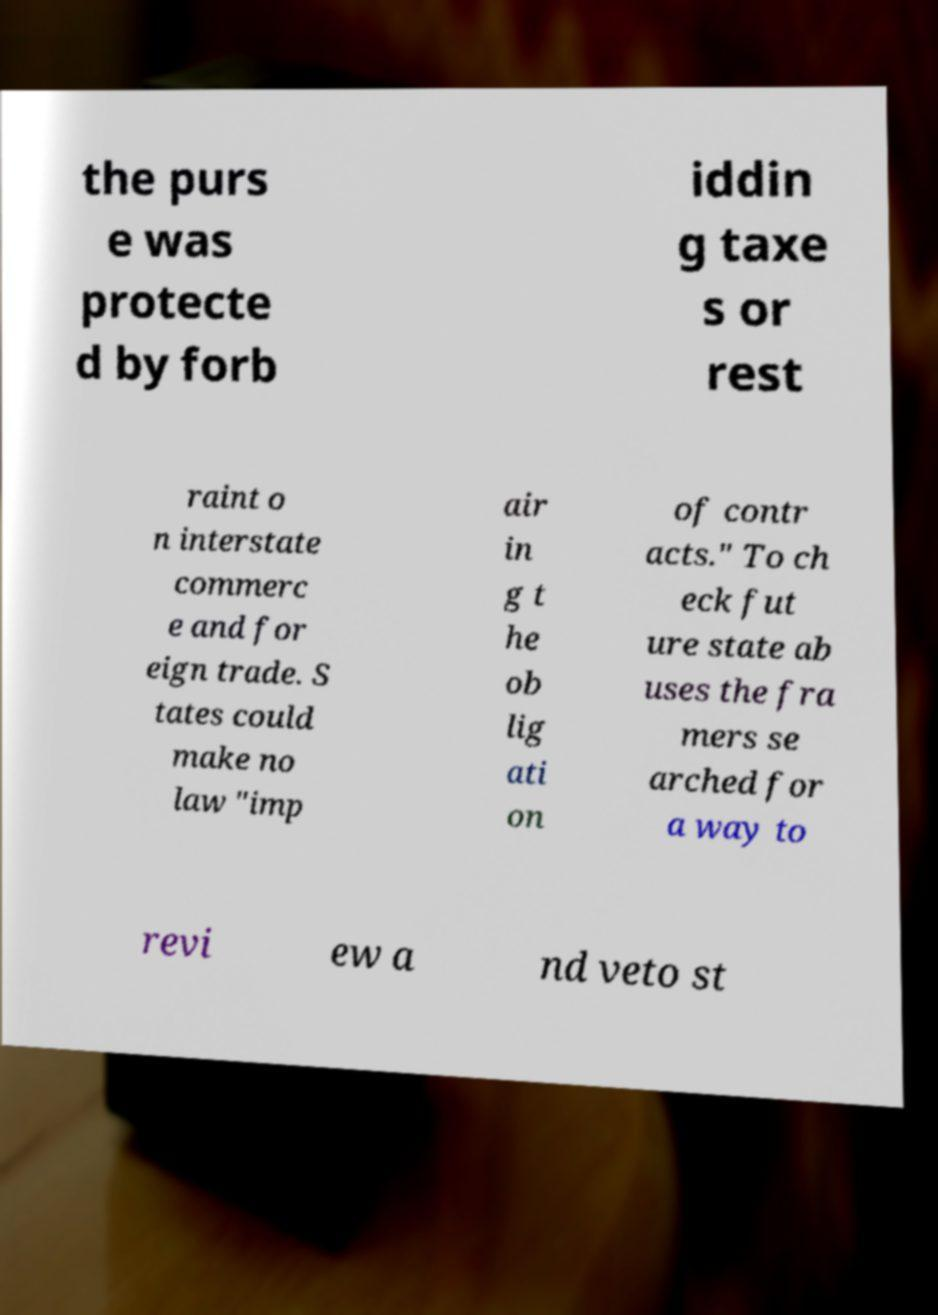For documentation purposes, I need the text within this image transcribed. Could you provide that? the purs e was protecte d by forb iddin g taxe s or rest raint o n interstate commerc e and for eign trade. S tates could make no law "imp air in g t he ob lig ati on of contr acts." To ch eck fut ure state ab uses the fra mers se arched for a way to revi ew a nd veto st 